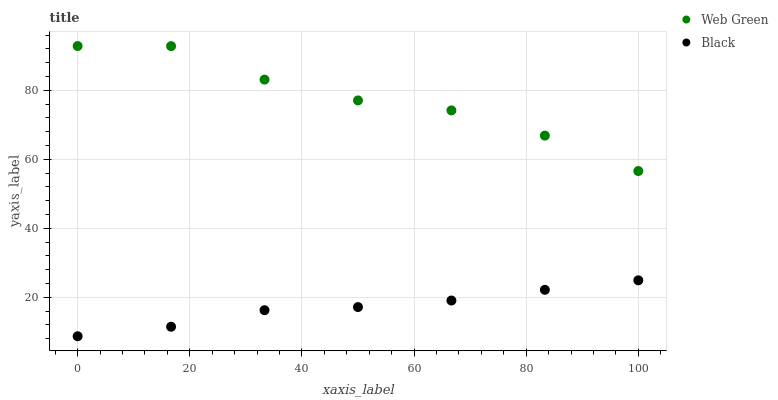Does Black have the minimum area under the curve?
Answer yes or no. Yes. Does Web Green have the maximum area under the curve?
Answer yes or no. Yes. Does Web Green have the minimum area under the curve?
Answer yes or no. No. Is Black the smoothest?
Answer yes or no. Yes. Is Web Green the roughest?
Answer yes or no. Yes. Is Web Green the smoothest?
Answer yes or no. No. Does Black have the lowest value?
Answer yes or no. Yes. Does Web Green have the lowest value?
Answer yes or no. No. Does Web Green have the highest value?
Answer yes or no. Yes. Is Black less than Web Green?
Answer yes or no. Yes. Is Web Green greater than Black?
Answer yes or no. Yes. Does Black intersect Web Green?
Answer yes or no. No. 